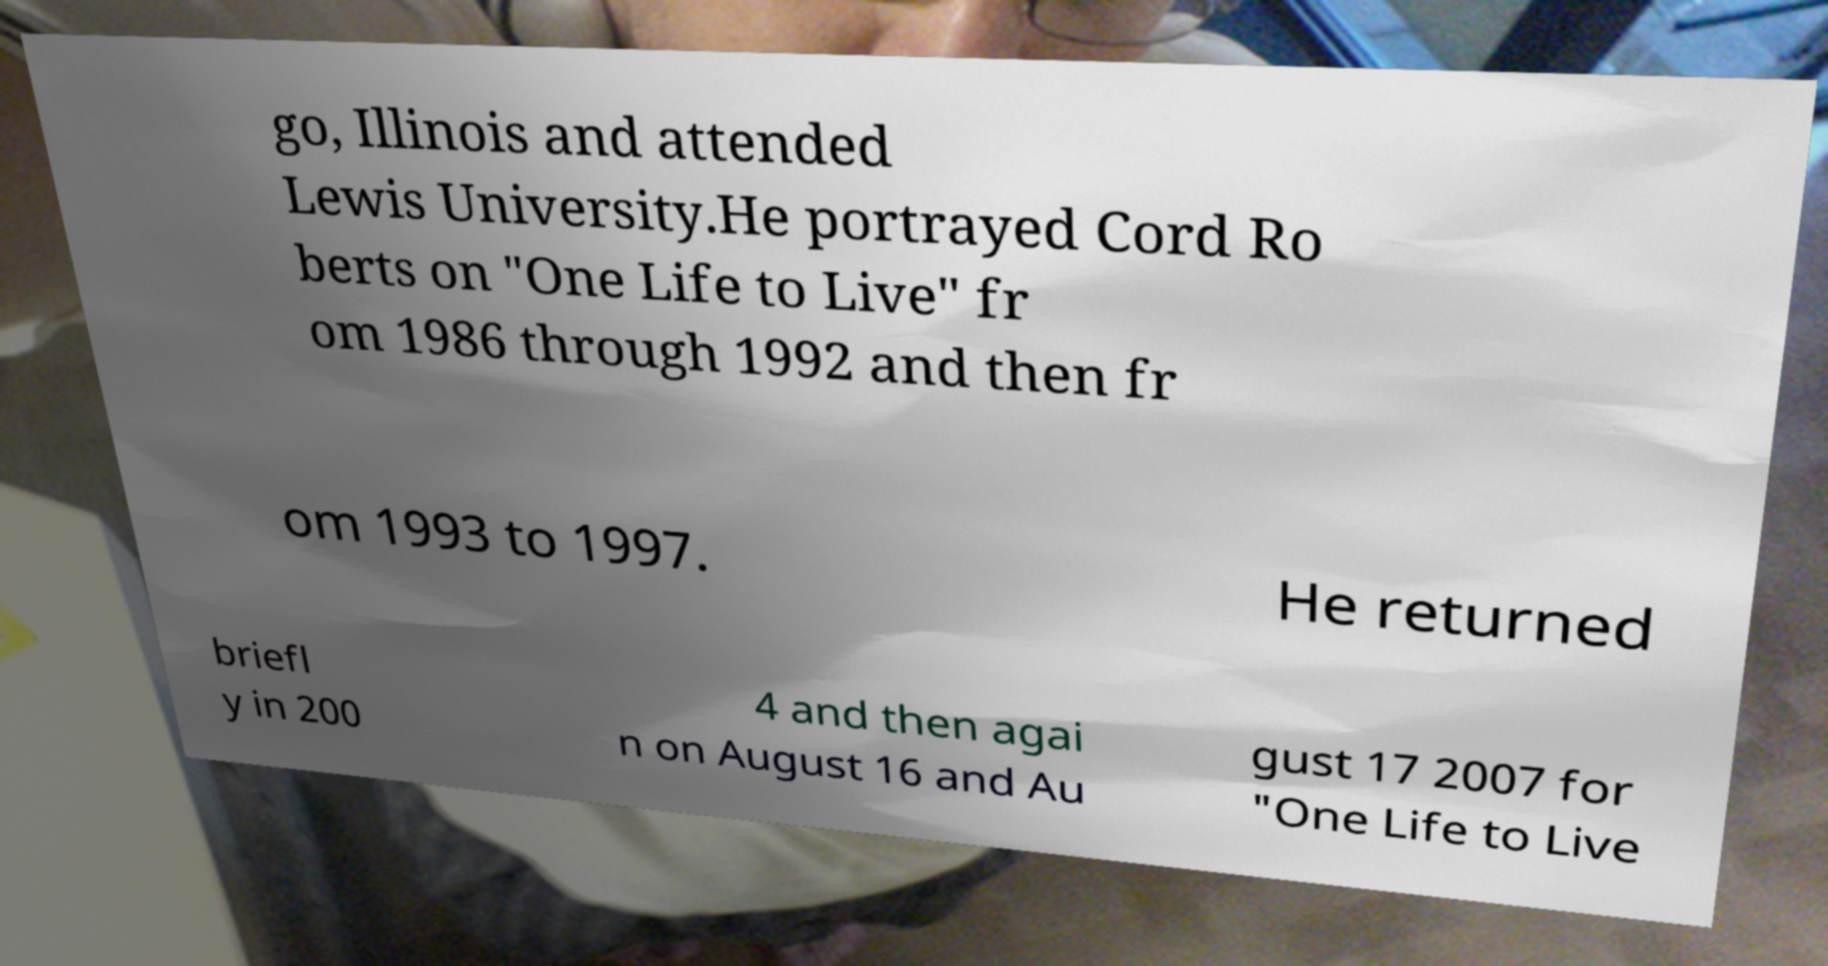For documentation purposes, I need the text within this image transcribed. Could you provide that? go, Illinois and attended Lewis University.He portrayed Cord Ro berts on "One Life to Live" fr om 1986 through 1992 and then fr om 1993 to 1997. He returned briefl y in 200 4 and then agai n on August 16 and Au gust 17 2007 for "One Life to Live 